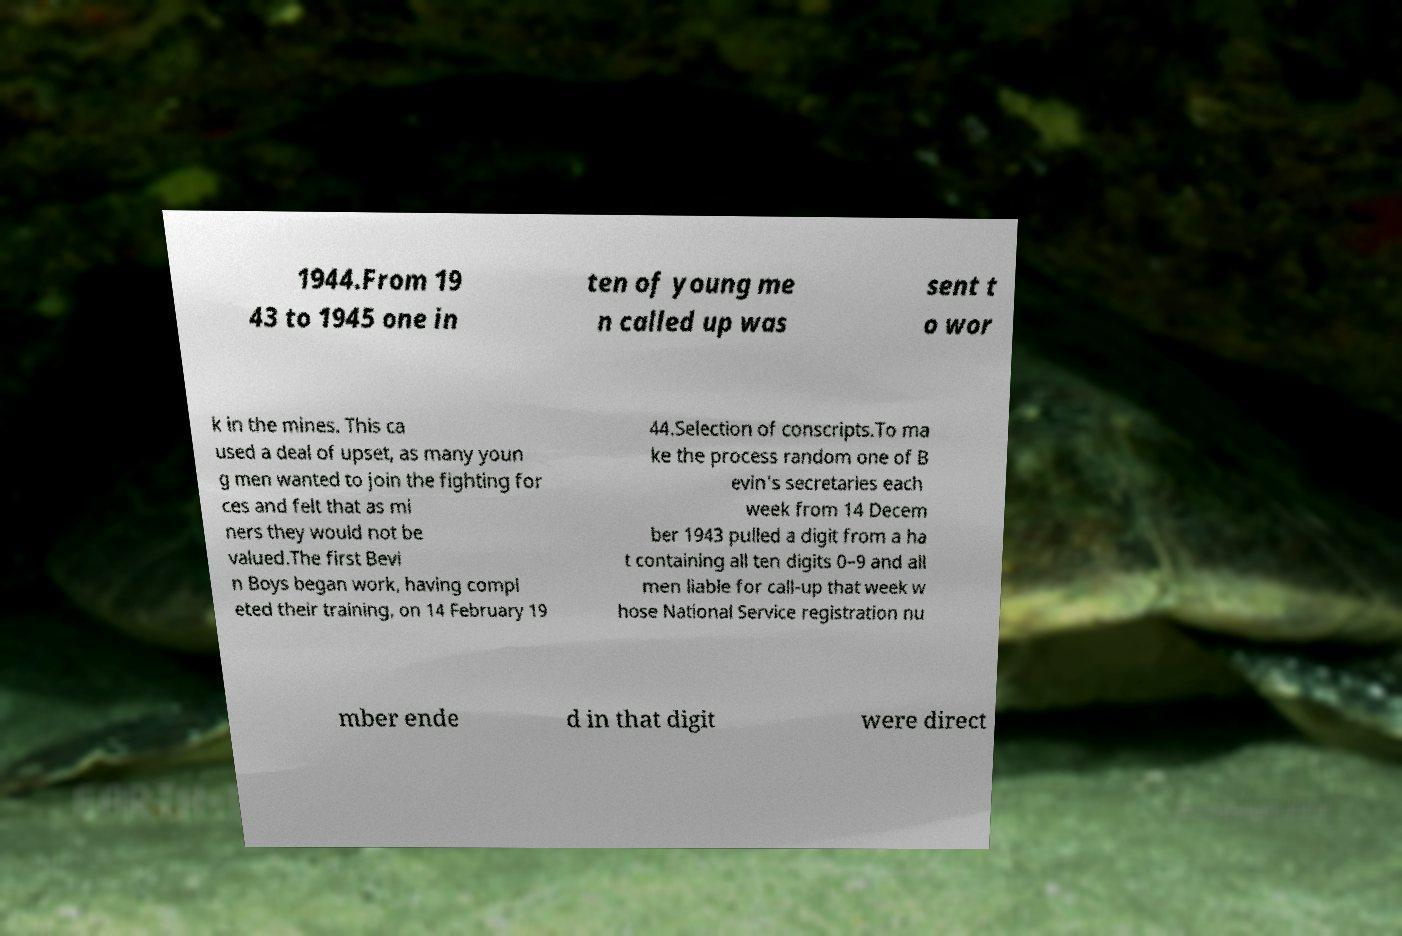For documentation purposes, I need the text within this image transcribed. Could you provide that? 1944.From 19 43 to 1945 one in ten of young me n called up was sent t o wor k in the mines. This ca used a deal of upset, as many youn g men wanted to join the fighting for ces and felt that as mi ners they would not be valued.The first Bevi n Boys began work, having compl eted their training, on 14 February 19 44.Selection of conscripts.To ma ke the process random one of B evin's secretaries each week from 14 Decem ber 1943 pulled a digit from a ha t containing all ten digits 0–9 and all men liable for call-up that week w hose National Service registration nu mber ende d in that digit were direct 